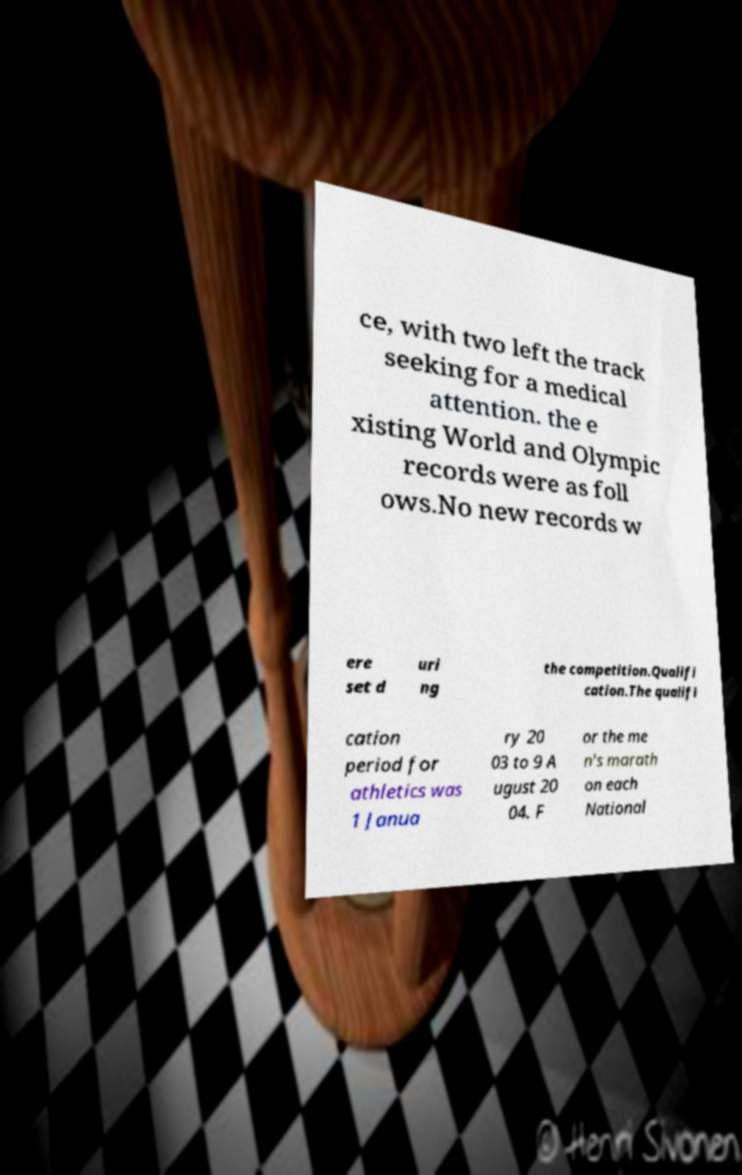Can you read and provide the text displayed in the image?This photo seems to have some interesting text. Can you extract and type it out for me? ce, with two left the track seeking for a medical attention. the e xisting World and Olympic records were as foll ows.No new records w ere set d uri ng the competition.Qualifi cation.The qualifi cation period for athletics was 1 Janua ry 20 03 to 9 A ugust 20 04. F or the me n's marath on each National 